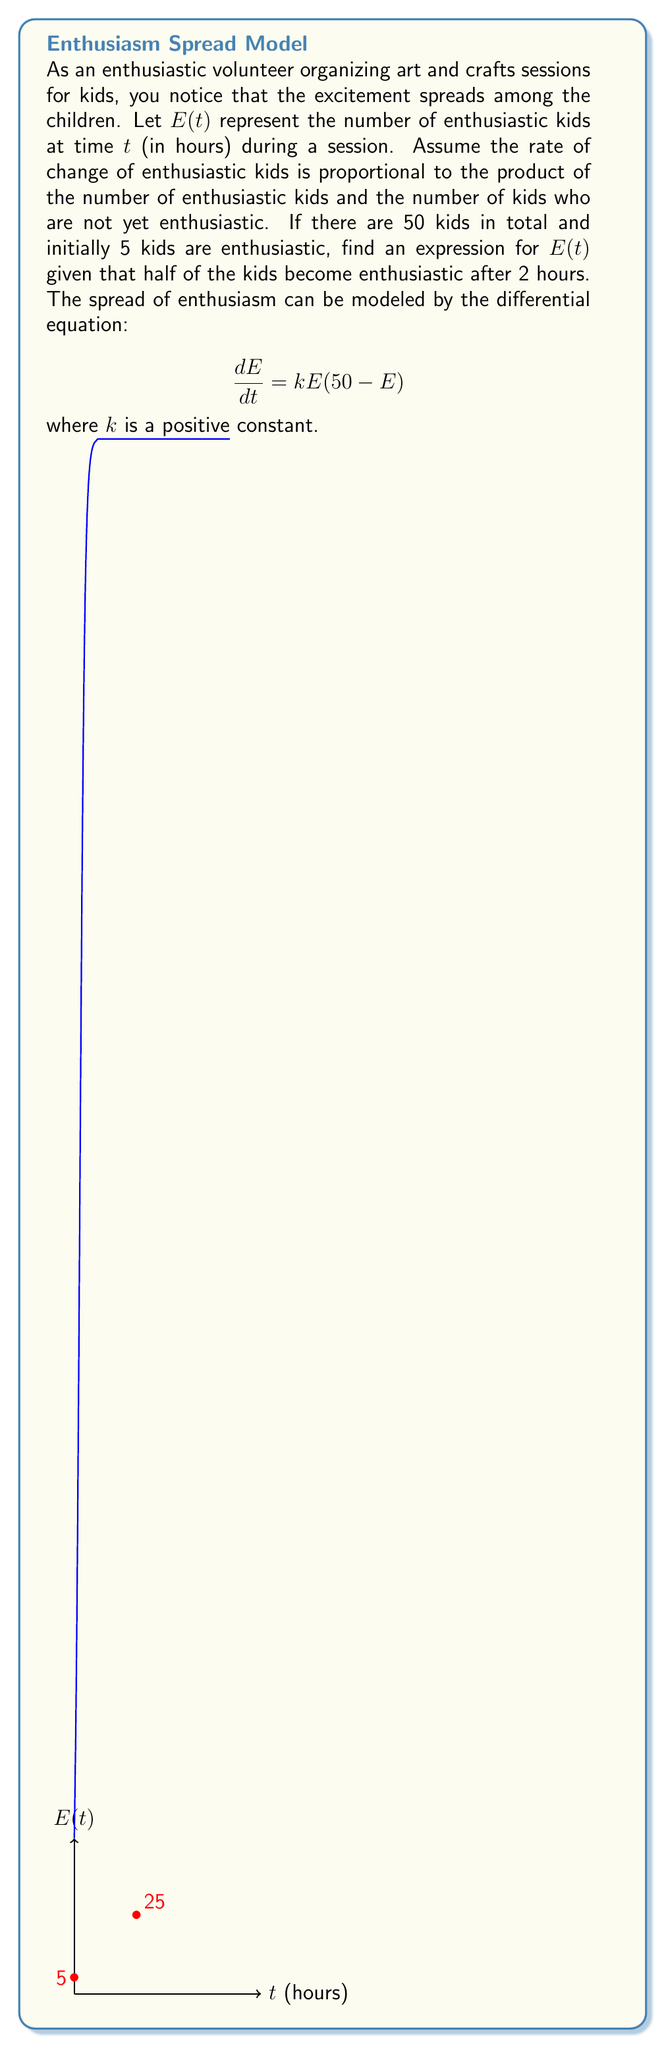What is the answer to this math problem? Let's solve this problem step by step:

1) The given differential equation is:
   $$\frac{dE}{dt} = kE(50-E)$$

2) This is a separable equation. Let's separate the variables:
   $$\frac{dE}{E(50-E)} = kdt$$

3) Integrate both sides:
   $$\int \frac{dE}{E(50-E)} = \int kdt$$

4) The left side can be integrated using partial fractions:
   $$\frac{1}{50} \ln|\frac{E}{50-E}| = kt + C$$

5) Solve for $E$:
   $$\frac{E}{50-E} = Ce^{50kt}$$
   $$E = \frac{50Ce^{50kt}}{1+Ce^{50kt}}$$

6) Use the initial condition: $E(0) = 5$
   $$5 = \frac{50C}{1+C}$$
   $$C = \frac{1}{9}$$

7) Now our equation is:
   $$E = \frac{50(\frac{1}{9})e^{50kt}}{1+(\frac{1}{9})e^{50kt}} = \frac{50}{9e^{-50kt}+1}$$

8) Use the condition that half of the kids (25) are enthusiastic after 2 hours:
   $$25 = \frac{50}{9e^{-100k}+1}$$

9) Solve for $k$:
   $$9e^{-100k} = 1$$
   $$e^{-100k} = \frac{1}{9}$$
   $$-100k = \ln(\frac{1}{9})$$
   $$k = -\frac{1}{100}\ln(\frac{1}{9}) = \frac{\ln(9)}{100}$$

10) Substitute this value of $k$ back into our equation for $E(t)$:
    $$E(t) = \frac{50}{9e^{-50(\frac{\ln(9)}{100})t}+1} = \frac{50}{9e^{-\frac{\ln(9)}{2}t}+1}$$

11) Simplify:
    $$E(t) = \frac{50}{9(9^{-t/2})+1} = \frac{50}{9^{1-t/2}+1}$$
Answer: $E(t) = \frac{50}{9^{1-t/2}+1}$ 